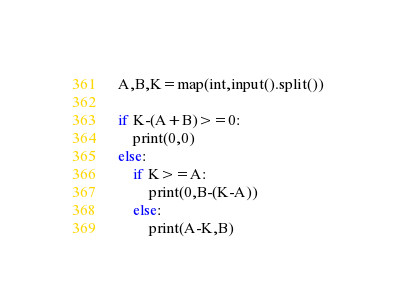<code> <loc_0><loc_0><loc_500><loc_500><_Python_>A,B,K=map(int,input().split())

if K-(A+B)>=0:
    print(0,0)
else:
    if K>=A:
        print(0,B-(K-A))
    else:
        print(A-K,B)</code> 